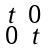Convert formula to latex. <formula><loc_0><loc_0><loc_500><loc_500>\begin{smallmatrix} t & 0 \\ 0 & t \\ \end{smallmatrix}</formula> 